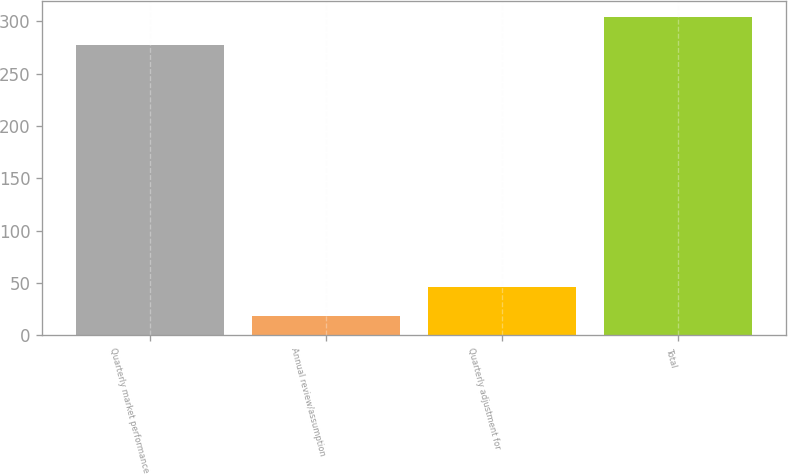Convert chart. <chart><loc_0><loc_0><loc_500><loc_500><bar_chart><fcel>Quarterly market performance<fcel>Annual review/assumption<fcel>Quarterly adjustment for<fcel>Total<nl><fcel>277<fcel>19<fcel>46.3<fcel>304.3<nl></chart> 